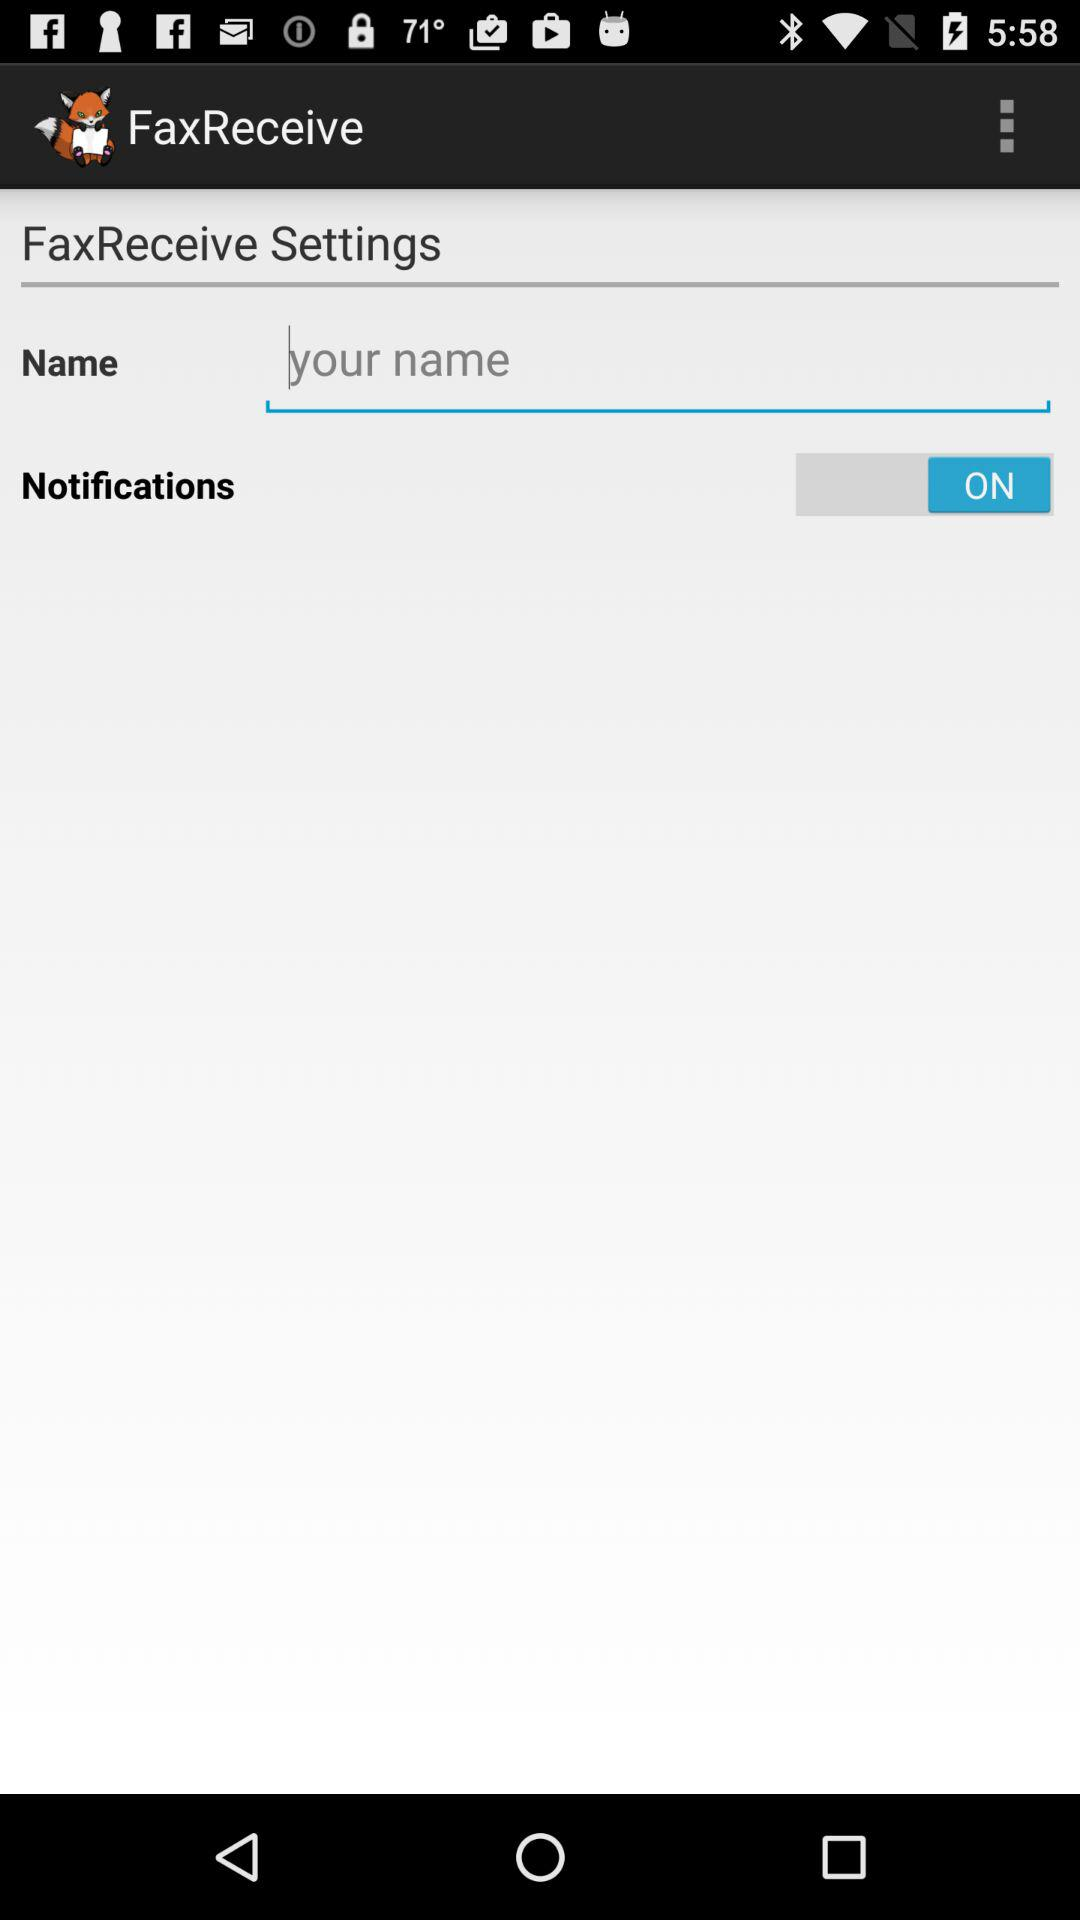What is the status of notifications? The status is "ON". 